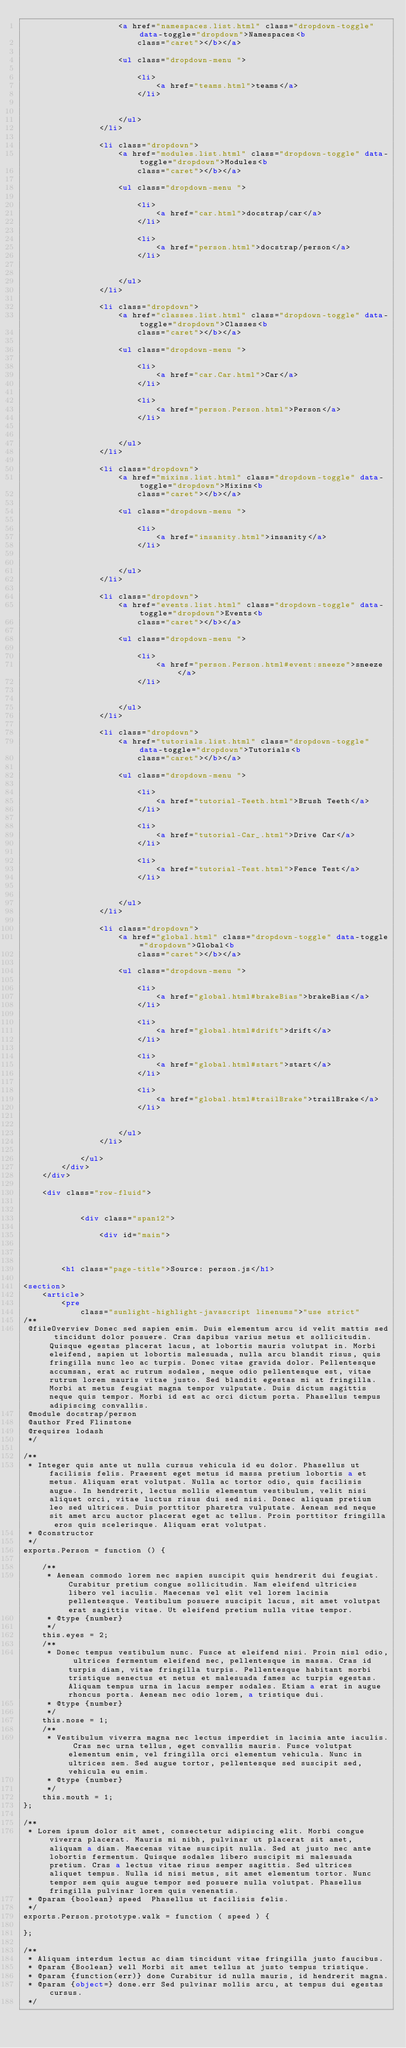<code> <loc_0><loc_0><loc_500><loc_500><_HTML_>					<a href="namespaces.list.html" class="dropdown-toggle" data-toggle="dropdown">Namespaces<b
						class="caret"></b></a>

					<ul class="dropdown-menu ">
						
						<li>
							<a href="teams.html">teams</a>
						</li>
						

					</ul>
				</li>
				
				<li class="dropdown">
					<a href="modules.list.html" class="dropdown-toggle" data-toggle="dropdown">Modules<b
						class="caret"></b></a>

					<ul class="dropdown-menu ">
						
						<li>
							<a href="car.html">docstrap/car</a>
						</li>
						
						<li>
							<a href="person.html">docstrap/person</a>
						</li>
						

					</ul>
				</li>
				
				<li class="dropdown">
					<a href="classes.list.html" class="dropdown-toggle" data-toggle="dropdown">Classes<b
						class="caret"></b></a>

					<ul class="dropdown-menu ">
						
						<li>
							<a href="car.Car.html">Car</a>
						</li>
						
						<li>
							<a href="person.Person.html">Person</a>
						</li>
						

					</ul>
				</li>
				
				<li class="dropdown">
					<a href="mixins.list.html" class="dropdown-toggle" data-toggle="dropdown">Mixins<b
						class="caret"></b></a>

					<ul class="dropdown-menu ">
						
						<li>
							<a href="insanity.html">insanity</a>
						</li>
						

					</ul>
				</li>
				
				<li class="dropdown">
					<a href="events.list.html" class="dropdown-toggle" data-toggle="dropdown">Events<b
						class="caret"></b></a>

					<ul class="dropdown-menu ">
						
						<li>
							<a href="person.Person.html#event:sneeze">sneeze</a>
						</li>
						

					</ul>
				</li>
				
				<li class="dropdown">
					<a href="tutorials.list.html" class="dropdown-toggle" data-toggle="dropdown">Tutorials<b
						class="caret"></b></a>

					<ul class="dropdown-menu ">
						
						<li>
							<a href="tutorial-Teeth.html">Brush Teeth</a>
						</li>
						
						<li>
							<a href="tutorial-Car_.html">Drive Car</a>
						</li>
						
						<li>
							<a href="tutorial-Test.html">Fence Test</a>
						</li>
						

					</ul>
				</li>
				
				<li class="dropdown">
					<a href="global.html" class="dropdown-toggle" data-toggle="dropdown">Global<b
						class="caret"></b></a>

					<ul class="dropdown-menu ">
						
						<li>
							<a href="global.html#brakeBias">brakeBias</a>
						</li>
						
						<li>
							<a href="global.html#drift">drift</a>
						</li>
						
						<li>
							<a href="global.html#start">start</a>
						</li>
						
						<li>
							<a href="global.html#trailBrake">trailBrake</a>
						</li>
						

					</ul>
				</li>
				
			</ul>
		</div>
	</div>

	<div class="row-fluid">

		
			<div class="span12">
				
				<div id="main">
					


		<h1 class="page-title">Source: person.js</h1>
    
<section>
	<article>
		<pre
			class="sunlight-highlight-javascript linenums">"use strict"
/**
 @fileOverview Donec sed sapien enim. Duis elementum arcu id velit mattis sed tincidunt dolor posuere. Cras dapibus varius metus et sollicitudin. Quisque egestas placerat lacus, at lobortis mauris volutpat in. Morbi eleifend, sapien ut lobortis malesuada, nulla arcu blandit risus, quis fringilla nunc leo ac turpis. Donec vitae gravida dolor. Pellentesque accumsan, erat ac rutrum sodales, neque odio pellentesque est, vitae rutrum lorem mauris vitae justo. Sed blandit egestas mi at fringilla. Morbi at metus feugiat magna tempor vulputate. Duis dictum sagittis neque quis tempor. Morbi id est ac orci dictum porta. Phasellus tempus adipiscing convallis.
 @module docstrap/person
 @author Fred Flinstone
 @requires lodash
 */

/**
 * Integer quis ante ut nulla cursus vehicula id eu dolor. Phasellus ut facilisis felis. Praesent eget metus id massa pretium lobortis a et metus. Aliquam erat volutpat. Nulla ac tortor odio, quis facilisis augue. In hendrerit, lectus mollis elementum vestibulum, velit nisi aliquet orci, vitae luctus risus dui sed nisi. Donec aliquam pretium leo sed ultrices. Duis porttitor pharetra vulputate. Aenean sed neque sit amet arcu auctor placerat eget ac tellus. Proin porttitor fringilla eros quis scelerisque. Aliquam erat volutpat.
 * @constructor
 */
exports.Person = function () {

	/**
	 * Aenean commodo lorem nec sapien suscipit quis hendrerit dui feugiat. Curabitur pretium congue sollicitudin. Nam eleifend ultricies libero vel iaculis. Maecenas vel elit vel lorem lacinia pellentesque. Vestibulum posuere suscipit lacus, sit amet volutpat erat sagittis vitae. Ut eleifend pretium nulla vitae tempor.
	 * @type {number}
	 */
	this.eyes = 2;
	/**
	 * Donec tempus vestibulum nunc. Fusce at eleifend nisi. Proin nisl odio, ultrices fermentum eleifend nec, pellentesque in massa. Cras id turpis diam, vitae fringilla turpis. Pellentesque habitant morbi tristique senectus et netus et malesuada fames ac turpis egestas. Aliquam tempus urna in lacus semper sodales. Etiam a erat in augue rhoncus porta. Aenean nec odio lorem, a tristique dui.
	 * @type {number}
	 */
	this.nose = 1;
	/**
	 * Vestibulum viverra magna nec lectus imperdiet in lacinia ante iaculis. Cras nec urna tellus, eget convallis mauris. Fusce volutpat elementum enim, vel fringilla orci elementum vehicula. Nunc in ultrices sem. Sed augue tortor, pellentesque sed suscipit sed, vehicula eu enim.
	 * @type {number}
	 */
	this.mouth = 1;
};

/**
 * Lorem ipsum dolor sit amet, consectetur adipiscing elit. Morbi congue viverra placerat. Mauris mi nibh, pulvinar ut placerat sit amet, aliquam a diam. Maecenas vitae suscipit nulla. Sed at justo nec ante lobortis fermentum. Quisque sodales libero suscipit mi malesuada pretium. Cras a lectus vitae risus semper sagittis. Sed ultrices aliquet tempus. Nulla id nisi metus, sit amet elementum tortor. Nunc tempor sem quis augue tempor sed posuere nulla volutpat. Phasellus fringilla pulvinar lorem quis venenatis.
 * @param {boolean} speed  Phasellus ut facilisis felis.
 */
exports.Person.prototype.walk = function ( speed ) {

};

/**
 * Aliquam interdum lectus ac diam tincidunt vitae fringilla justo faucibus.
 * @param {Boolean} well Morbi sit amet tellus at justo tempus tristique.
 * @param {function(err)} done Curabitur id nulla mauris, id hendrerit magna.
 * @param {object=} done.err Sed pulvinar mollis arcu, at tempus dui egestas cursus.
 */</code> 